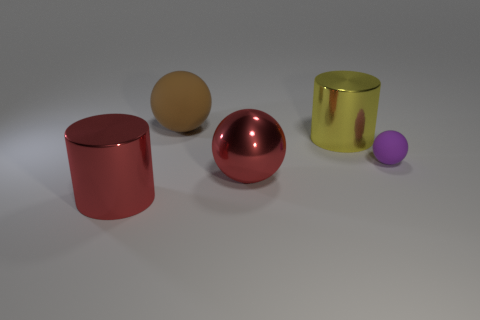Is the number of shiny cylinders that are behind the large yellow metallic thing less than the number of tiny cyan matte things?
Give a very brief answer. No. What is the material of the yellow object that is the same size as the red metal ball?
Keep it short and to the point. Metal. There is a metallic thing that is both in front of the large yellow metal thing and to the right of the brown sphere; what is its size?
Keep it short and to the point. Large. What size is the other metal object that is the same shape as the large yellow object?
Offer a very short reply. Large. What number of things are tiny purple rubber balls or large balls in front of the purple thing?
Your answer should be very brief. 2. The big yellow shiny object has what shape?
Ensure brevity in your answer.  Cylinder. The rubber object that is behind the rubber ball in front of the large brown object is what shape?
Provide a short and direct response. Sphere. What is the material of the object that is the same color as the shiny sphere?
Ensure brevity in your answer.  Metal. There is a ball that is the same material as the small object; what color is it?
Your answer should be very brief. Brown. Is there anything else that has the same size as the red cylinder?
Your answer should be compact. Yes. 